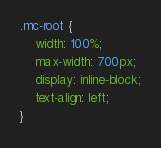<code> <loc_0><loc_0><loc_500><loc_500><_CSS_>.mc-root {
    width: 100%;
    max-width: 700px;
    display: inline-block;
    text-align: left;
}
</code> 